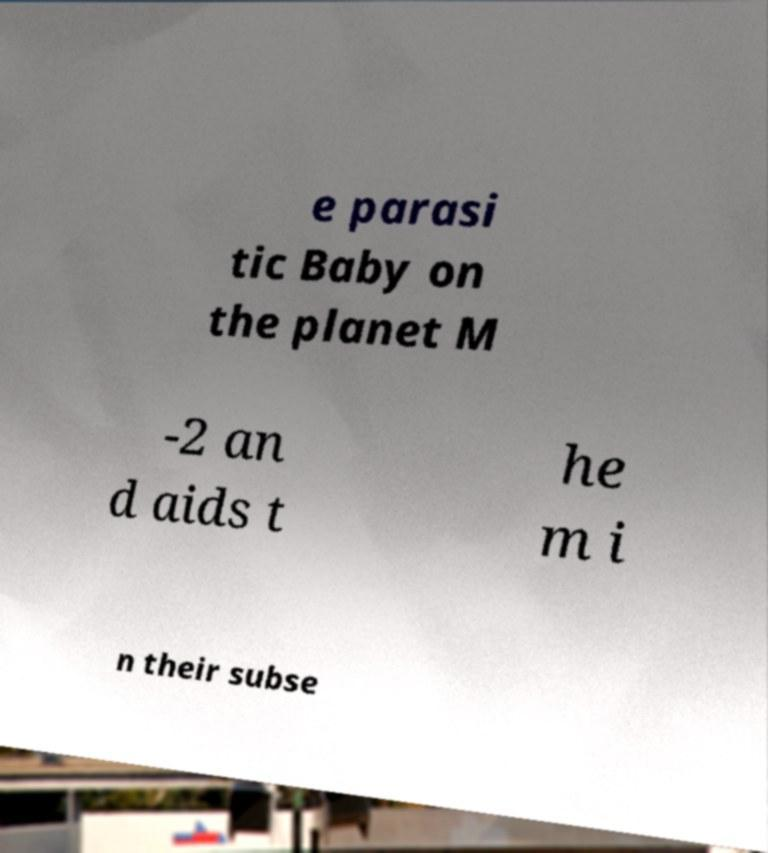There's text embedded in this image that I need extracted. Can you transcribe it verbatim? e parasi tic Baby on the planet M -2 an d aids t he m i n their subse 